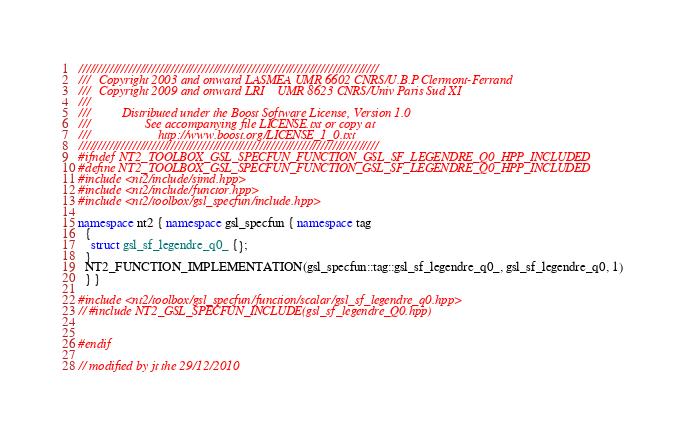Convert code to text. <code><loc_0><loc_0><loc_500><loc_500><_C++_>//////////////////////////////////////////////////////////////////////////////
///   Copyright 2003 and onward LASMEA UMR 6602 CNRS/U.B.P Clermont-Ferrand
///   Copyright 2009 and onward LRI    UMR 8623 CNRS/Univ Paris Sud XI
///
///          Distributed under the Boost Software License, Version 1.0
///                 See accompanying file LICENSE.txt or copy at
///                     http://www.boost.org/LICENSE_1_0.txt
//////////////////////////////////////////////////////////////////////////////
#ifndef NT2_TOOLBOX_GSL_SPECFUN_FUNCTION_GSL_SF_LEGENDRE_Q0_HPP_INCLUDED
#define NT2_TOOLBOX_GSL_SPECFUN_FUNCTION_GSL_SF_LEGENDRE_Q0_HPP_INCLUDED
#include <nt2/include/simd.hpp>
#include <nt2/include/functor.hpp>
#include <nt2/toolbox/gsl_specfun/include.hpp>

namespace nt2 { namespace gsl_specfun { namespace tag
  {         
    struct gsl_sf_legendre_q0_ {};
  }
  NT2_FUNCTION_IMPLEMENTATION(gsl_specfun::tag::gsl_sf_legendre_q0_, gsl_sf_legendre_q0, 1)
  } }
 
#include <nt2/toolbox/gsl_specfun/function/scalar/gsl_sf_legendre_q0.hpp>
// #include NT2_GSL_SPECFUN_INCLUDE(gsl_sf_legendre_Q0.hpp) 

 
#endif

// modified by jt the 29/12/2010</code> 